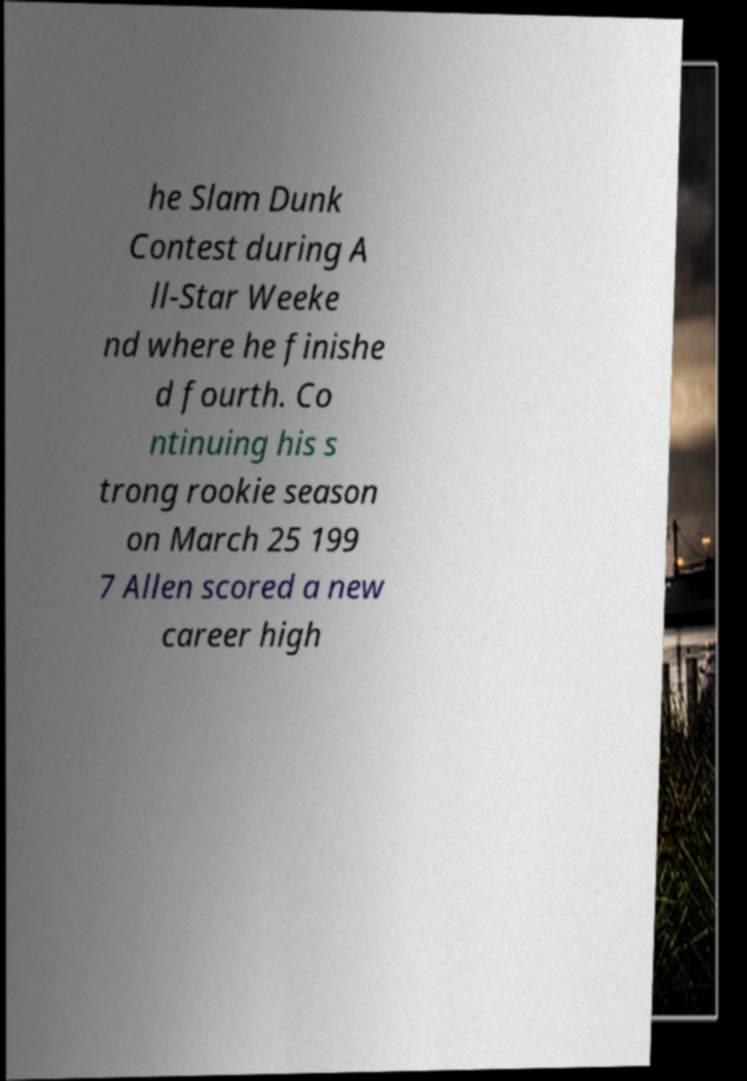Can you accurately transcribe the text from the provided image for me? he Slam Dunk Contest during A ll-Star Weeke nd where he finishe d fourth. Co ntinuing his s trong rookie season on March 25 199 7 Allen scored a new career high 